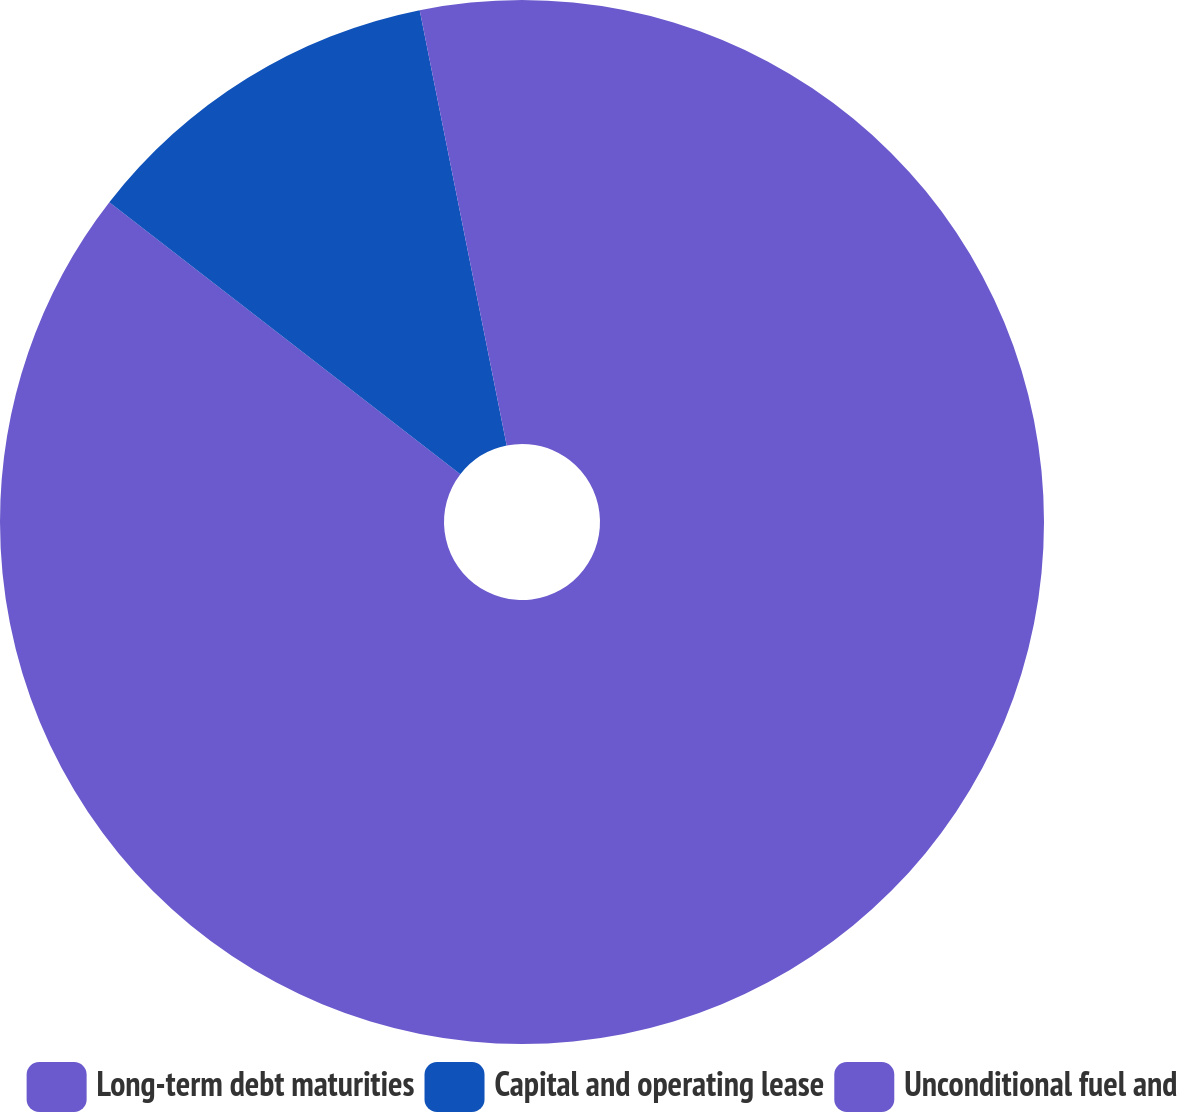<chart> <loc_0><loc_0><loc_500><loc_500><pie_chart><fcel>Long-term debt maturities<fcel>Capital and operating lease<fcel>Unconditional fuel and<nl><fcel>85.49%<fcel>11.37%<fcel>3.14%<nl></chart> 